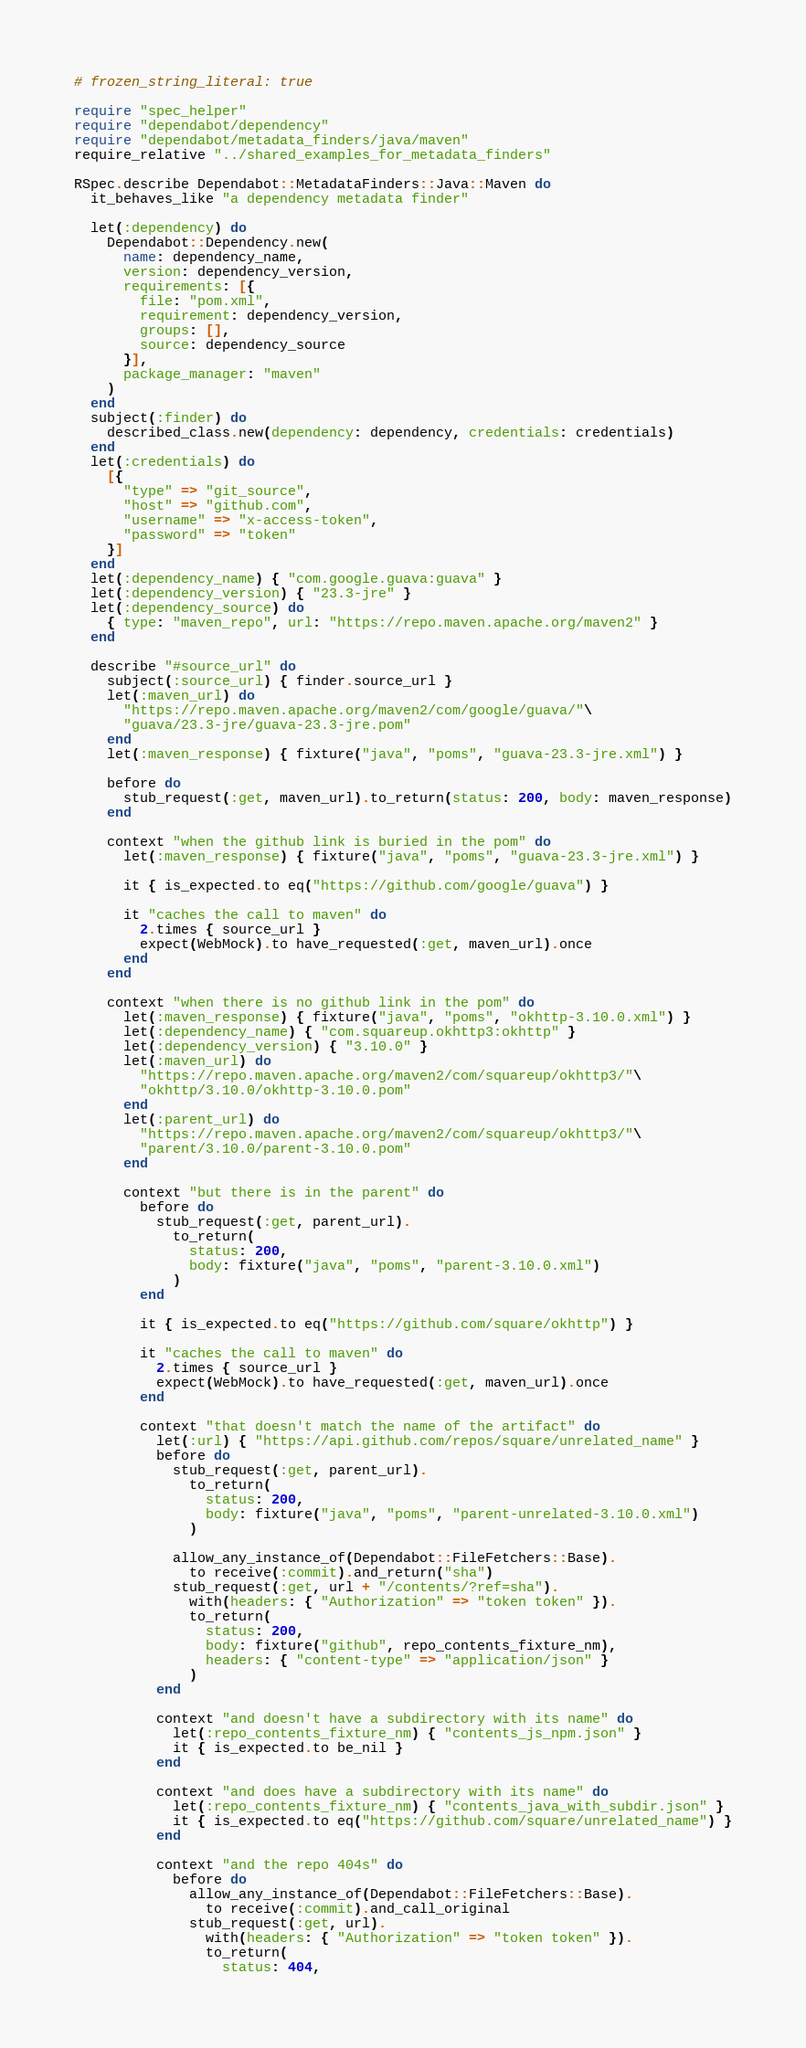<code> <loc_0><loc_0><loc_500><loc_500><_Ruby_># frozen_string_literal: true

require "spec_helper"
require "dependabot/dependency"
require "dependabot/metadata_finders/java/maven"
require_relative "../shared_examples_for_metadata_finders"

RSpec.describe Dependabot::MetadataFinders::Java::Maven do
  it_behaves_like "a dependency metadata finder"

  let(:dependency) do
    Dependabot::Dependency.new(
      name: dependency_name,
      version: dependency_version,
      requirements: [{
        file: "pom.xml",
        requirement: dependency_version,
        groups: [],
        source: dependency_source
      }],
      package_manager: "maven"
    )
  end
  subject(:finder) do
    described_class.new(dependency: dependency, credentials: credentials)
  end
  let(:credentials) do
    [{
      "type" => "git_source",
      "host" => "github.com",
      "username" => "x-access-token",
      "password" => "token"
    }]
  end
  let(:dependency_name) { "com.google.guava:guava" }
  let(:dependency_version) { "23.3-jre" }
  let(:dependency_source) do
    { type: "maven_repo", url: "https://repo.maven.apache.org/maven2" }
  end

  describe "#source_url" do
    subject(:source_url) { finder.source_url }
    let(:maven_url) do
      "https://repo.maven.apache.org/maven2/com/google/guava/"\
      "guava/23.3-jre/guava-23.3-jre.pom"
    end
    let(:maven_response) { fixture("java", "poms", "guava-23.3-jre.xml") }

    before do
      stub_request(:get, maven_url).to_return(status: 200, body: maven_response)
    end

    context "when the github link is buried in the pom" do
      let(:maven_response) { fixture("java", "poms", "guava-23.3-jre.xml") }

      it { is_expected.to eq("https://github.com/google/guava") }

      it "caches the call to maven" do
        2.times { source_url }
        expect(WebMock).to have_requested(:get, maven_url).once
      end
    end

    context "when there is no github link in the pom" do
      let(:maven_response) { fixture("java", "poms", "okhttp-3.10.0.xml") }
      let(:dependency_name) { "com.squareup.okhttp3:okhttp" }
      let(:dependency_version) { "3.10.0" }
      let(:maven_url) do
        "https://repo.maven.apache.org/maven2/com/squareup/okhttp3/"\
        "okhttp/3.10.0/okhttp-3.10.0.pom"
      end
      let(:parent_url) do
        "https://repo.maven.apache.org/maven2/com/squareup/okhttp3/"\
        "parent/3.10.0/parent-3.10.0.pom"
      end

      context "but there is in the parent" do
        before do
          stub_request(:get, parent_url).
            to_return(
              status: 200,
              body: fixture("java", "poms", "parent-3.10.0.xml")
            )
        end

        it { is_expected.to eq("https://github.com/square/okhttp") }

        it "caches the call to maven" do
          2.times { source_url }
          expect(WebMock).to have_requested(:get, maven_url).once
        end

        context "that doesn't match the name of the artifact" do
          let(:url) { "https://api.github.com/repos/square/unrelated_name" }
          before do
            stub_request(:get, parent_url).
              to_return(
                status: 200,
                body: fixture("java", "poms", "parent-unrelated-3.10.0.xml")
              )

            allow_any_instance_of(Dependabot::FileFetchers::Base).
              to receive(:commit).and_return("sha")
            stub_request(:get, url + "/contents/?ref=sha").
              with(headers: { "Authorization" => "token token" }).
              to_return(
                status: 200,
                body: fixture("github", repo_contents_fixture_nm),
                headers: { "content-type" => "application/json" }
              )
          end

          context "and doesn't have a subdirectory with its name" do
            let(:repo_contents_fixture_nm) { "contents_js_npm.json" }
            it { is_expected.to be_nil }
          end

          context "and does have a subdirectory with its name" do
            let(:repo_contents_fixture_nm) { "contents_java_with_subdir.json" }
            it { is_expected.to eq("https://github.com/square/unrelated_name") }
          end

          context "and the repo 404s" do
            before do
              allow_any_instance_of(Dependabot::FileFetchers::Base).
                to receive(:commit).and_call_original
              stub_request(:get, url).
                with(headers: { "Authorization" => "token token" }).
                to_return(
                  status: 404,</code> 